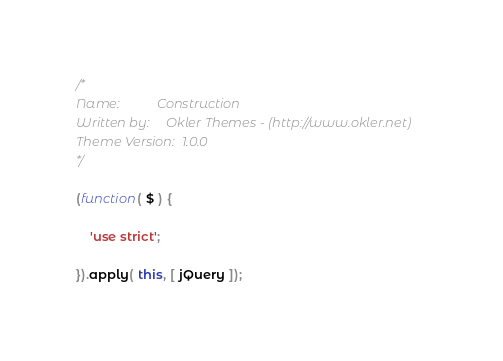Convert code to text. <code><loc_0><loc_0><loc_500><loc_500><_JavaScript_>/*
Name: 			Construction
Written by: 	Okler Themes - (http://www.okler.net)
Theme Version:	1.0.0
*/

(function( $ ) {

	'use strict';

}).apply( this, [ jQuery ]);</code> 